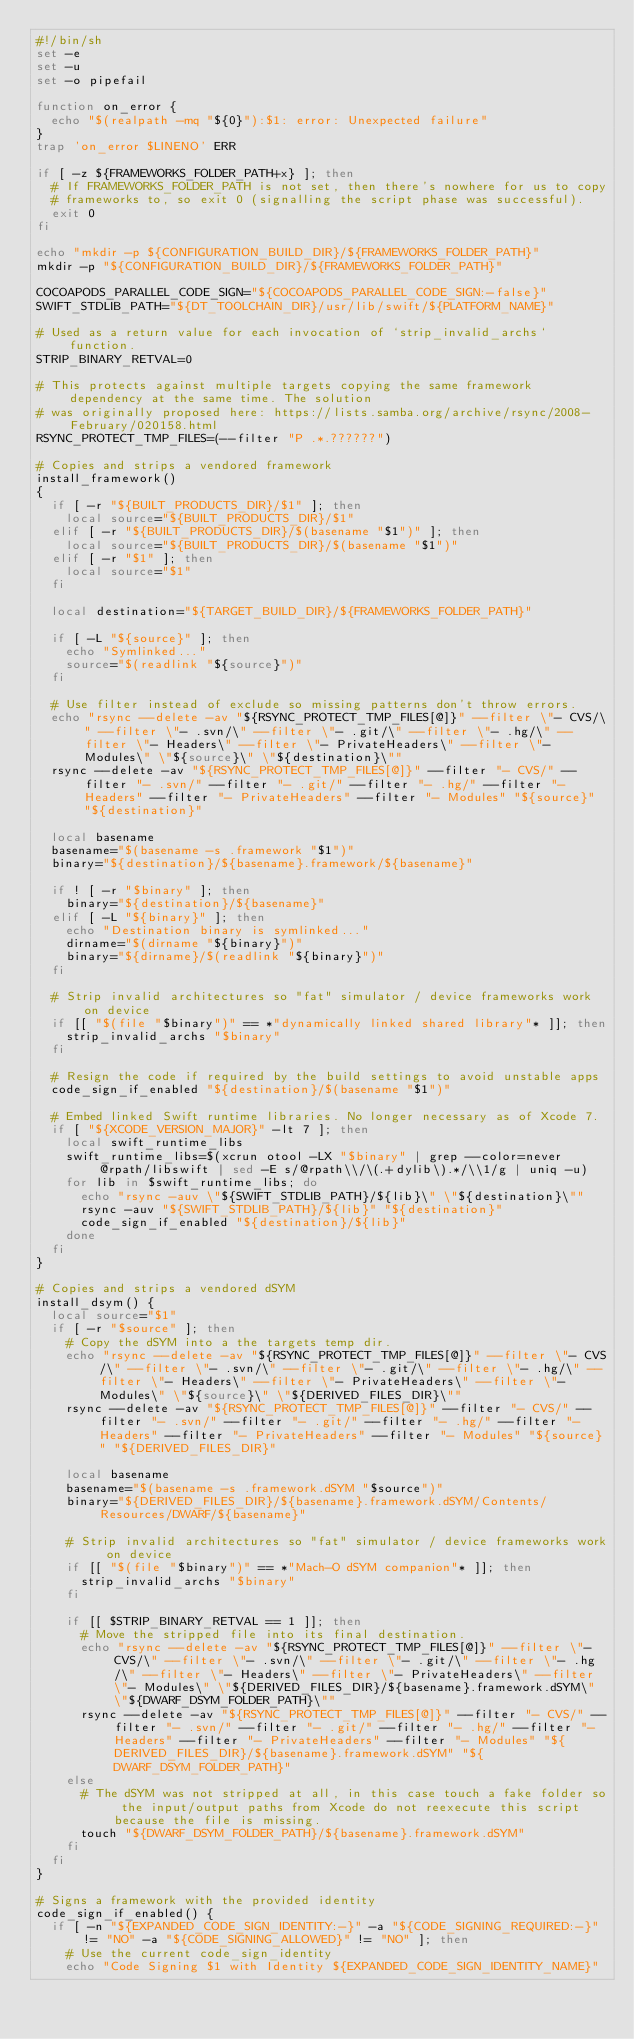Convert code to text. <code><loc_0><loc_0><loc_500><loc_500><_Bash_>#!/bin/sh
set -e
set -u
set -o pipefail

function on_error {
  echo "$(realpath -mq "${0}"):$1: error: Unexpected failure"
}
trap 'on_error $LINENO' ERR

if [ -z ${FRAMEWORKS_FOLDER_PATH+x} ]; then
  # If FRAMEWORKS_FOLDER_PATH is not set, then there's nowhere for us to copy
  # frameworks to, so exit 0 (signalling the script phase was successful).
  exit 0
fi

echo "mkdir -p ${CONFIGURATION_BUILD_DIR}/${FRAMEWORKS_FOLDER_PATH}"
mkdir -p "${CONFIGURATION_BUILD_DIR}/${FRAMEWORKS_FOLDER_PATH}"

COCOAPODS_PARALLEL_CODE_SIGN="${COCOAPODS_PARALLEL_CODE_SIGN:-false}"
SWIFT_STDLIB_PATH="${DT_TOOLCHAIN_DIR}/usr/lib/swift/${PLATFORM_NAME}"

# Used as a return value for each invocation of `strip_invalid_archs` function.
STRIP_BINARY_RETVAL=0

# This protects against multiple targets copying the same framework dependency at the same time. The solution
# was originally proposed here: https://lists.samba.org/archive/rsync/2008-February/020158.html
RSYNC_PROTECT_TMP_FILES=(--filter "P .*.??????")

# Copies and strips a vendored framework
install_framework()
{
  if [ -r "${BUILT_PRODUCTS_DIR}/$1" ]; then
    local source="${BUILT_PRODUCTS_DIR}/$1"
  elif [ -r "${BUILT_PRODUCTS_DIR}/$(basename "$1")" ]; then
    local source="${BUILT_PRODUCTS_DIR}/$(basename "$1")"
  elif [ -r "$1" ]; then
    local source="$1"
  fi

  local destination="${TARGET_BUILD_DIR}/${FRAMEWORKS_FOLDER_PATH}"

  if [ -L "${source}" ]; then
    echo "Symlinked..."
    source="$(readlink "${source}")"
  fi

  # Use filter instead of exclude so missing patterns don't throw errors.
  echo "rsync --delete -av "${RSYNC_PROTECT_TMP_FILES[@]}" --filter \"- CVS/\" --filter \"- .svn/\" --filter \"- .git/\" --filter \"- .hg/\" --filter \"- Headers\" --filter \"- PrivateHeaders\" --filter \"- Modules\" \"${source}\" \"${destination}\""
  rsync --delete -av "${RSYNC_PROTECT_TMP_FILES[@]}" --filter "- CVS/" --filter "- .svn/" --filter "- .git/" --filter "- .hg/" --filter "- Headers" --filter "- PrivateHeaders" --filter "- Modules" "${source}" "${destination}"

  local basename
  basename="$(basename -s .framework "$1")"
  binary="${destination}/${basename}.framework/${basename}"

  if ! [ -r "$binary" ]; then
    binary="${destination}/${basename}"
  elif [ -L "${binary}" ]; then
    echo "Destination binary is symlinked..."
    dirname="$(dirname "${binary}")"
    binary="${dirname}/$(readlink "${binary}")"
  fi

  # Strip invalid architectures so "fat" simulator / device frameworks work on device
  if [[ "$(file "$binary")" == *"dynamically linked shared library"* ]]; then
    strip_invalid_archs "$binary"
  fi

  # Resign the code if required by the build settings to avoid unstable apps
  code_sign_if_enabled "${destination}/$(basename "$1")"

  # Embed linked Swift runtime libraries. No longer necessary as of Xcode 7.
  if [ "${XCODE_VERSION_MAJOR}" -lt 7 ]; then
    local swift_runtime_libs
    swift_runtime_libs=$(xcrun otool -LX "$binary" | grep --color=never @rpath/libswift | sed -E s/@rpath\\/\(.+dylib\).*/\\1/g | uniq -u)
    for lib in $swift_runtime_libs; do
      echo "rsync -auv \"${SWIFT_STDLIB_PATH}/${lib}\" \"${destination}\""
      rsync -auv "${SWIFT_STDLIB_PATH}/${lib}" "${destination}"
      code_sign_if_enabled "${destination}/${lib}"
    done
  fi
}

# Copies and strips a vendored dSYM
install_dsym() {
  local source="$1"
  if [ -r "$source" ]; then
    # Copy the dSYM into a the targets temp dir.
    echo "rsync --delete -av "${RSYNC_PROTECT_TMP_FILES[@]}" --filter \"- CVS/\" --filter \"- .svn/\" --filter \"- .git/\" --filter \"- .hg/\" --filter \"- Headers\" --filter \"- PrivateHeaders\" --filter \"- Modules\" \"${source}\" \"${DERIVED_FILES_DIR}\""
    rsync --delete -av "${RSYNC_PROTECT_TMP_FILES[@]}" --filter "- CVS/" --filter "- .svn/" --filter "- .git/" --filter "- .hg/" --filter "- Headers" --filter "- PrivateHeaders" --filter "- Modules" "${source}" "${DERIVED_FILES_DIR}"

    local basename
    basename="$(basename -s .framework.dSYM "$source")"
    binary="${DERIVED_FILES_DIR}/${basename}.framework.dSYM/Contents/Resources/DWARF/${basename}"

    # Strip invalid architectures so "fat" simulator / device frameworks work on device
    if [[ "$(file "$binary")" == *"Mach-O dSYM companion"* ]]; then
      strip_invalid_archs "$binary"
    fi

    if [[ $STRIP_BINARY_RETVAL == 1 ]]; then
      # Move the stripped file into its final destination.
      echo "rsync --delete -av "${RSYNC_PROTECT_TMP_FILES[@]}" --filter \"- CVS/\" --filter \"- .svn/\" --filter \"- .git/\" --filter \"- .hg/\" --filter \"- Headers\" --filter \"- PrivateHeaders\" --filter \"- Modules\" \"${DERIVED_FILES_DIR}/${basename}.framework.dSYM\" \"${DWARF_DSYM_FOLDER_PATH}\""
      rsync --delete -av "${RSYNC_PROTECT_TMP_FILES[@]}" --filter "- CVS/" --filter "- .svn/" --filter "- .git/" --filter "- .hg/" --filter "- Headers" --filter "- PrivateHeaders" --filter "- Modules" "${DERIVED_FILES_DIR}/${basename}.framework.dSYM" "${DWARF_DSYM_FOLDER_PATH}"
    else
      # The dSYM was not stripped at all, in this case touch a fake folder so the input/output paths from Xcode do not reexecute this script because the file is missing.
      touch "${DWARF_DSYM_FOLDER_PATH}/${basename}.framework.dSYM"
    fi
  fi
}

# Signs a framework with the provided identity
code_sign_if_enabled() {
  if [ -n "${EXPANDED_CODE_SIGN_IDENTITY:-}" -a "${CODE_SIGNING_REQUIRED:-}" != "NO" -a "${CODE_SIGNING_ALLOWED}" != "NO" ]; then
    # Use the current code_sign_identity
    echo "Code Signing $1 with Identity ${EXPANDED_CODE_SIGN_IDENTITY_NAME}"</code> 